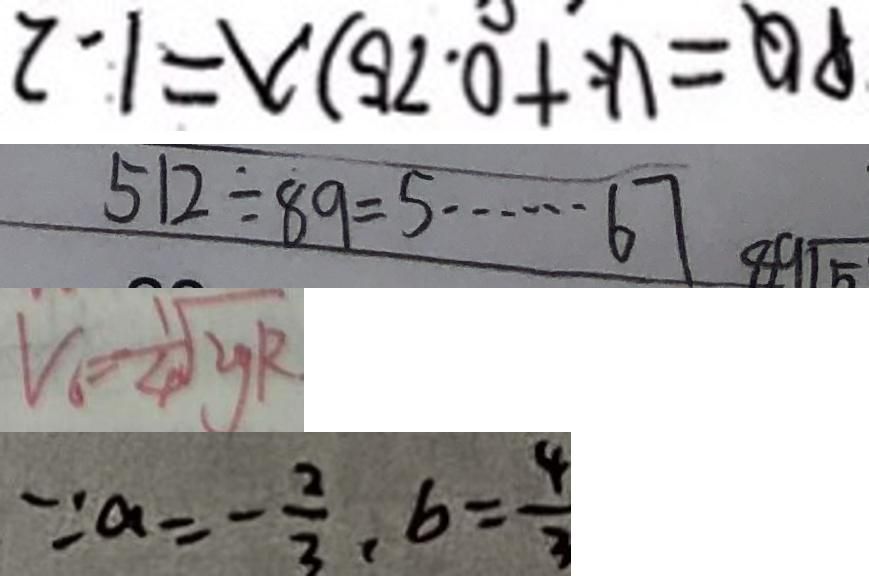<formula> <loc_0><loc_0><loc_500><loc_500>P Q = ( k + 0 . 7 5 ) \lambda = 1 . 2 
 5 1 2 \div 8 9 = 5 \cdots 6 7 
 V _ { 6 } = \frac { 1 } { 4 } \sqrt { y R } 
 \because a = - \frac { 2 } { 3 } , b = \frac { 4 } { 3 }</formula> 